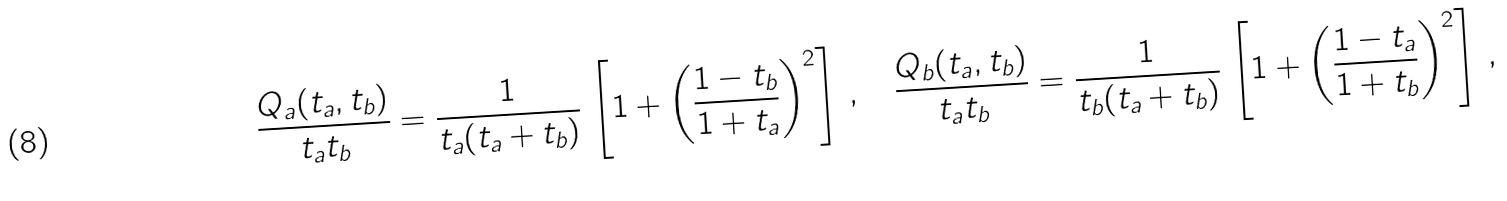Convert formula to latex. <formula><loc_0><loc_0><loc_500><loc_500>\frac { Q _ { a } ( t _ { a } , t _ { b } ) } { t _ { a } t _ { b } } = \frac { 1 } { t _ { a } ( t _ { a } + t _ { b } ) } \, \left [ 1 + \left ( \frac { 1 - t _ { b } } { 1 + t _ { a } } \right ) ^ { 2 } \right ] \, , \quad \frac { Q _ { b } ( t _ { a } , t _ { b } ) } { t _ { a } t _ { b } } = \frac { 1 } { t _ { b } ( t _ { a } + t _ { b } ) } \, \left [ 1 + \left ( \frac { 1 - t _ { a } } { 1 + t _ { b } } \right ) ^ { 2 } \right ] \, ,</formula> 